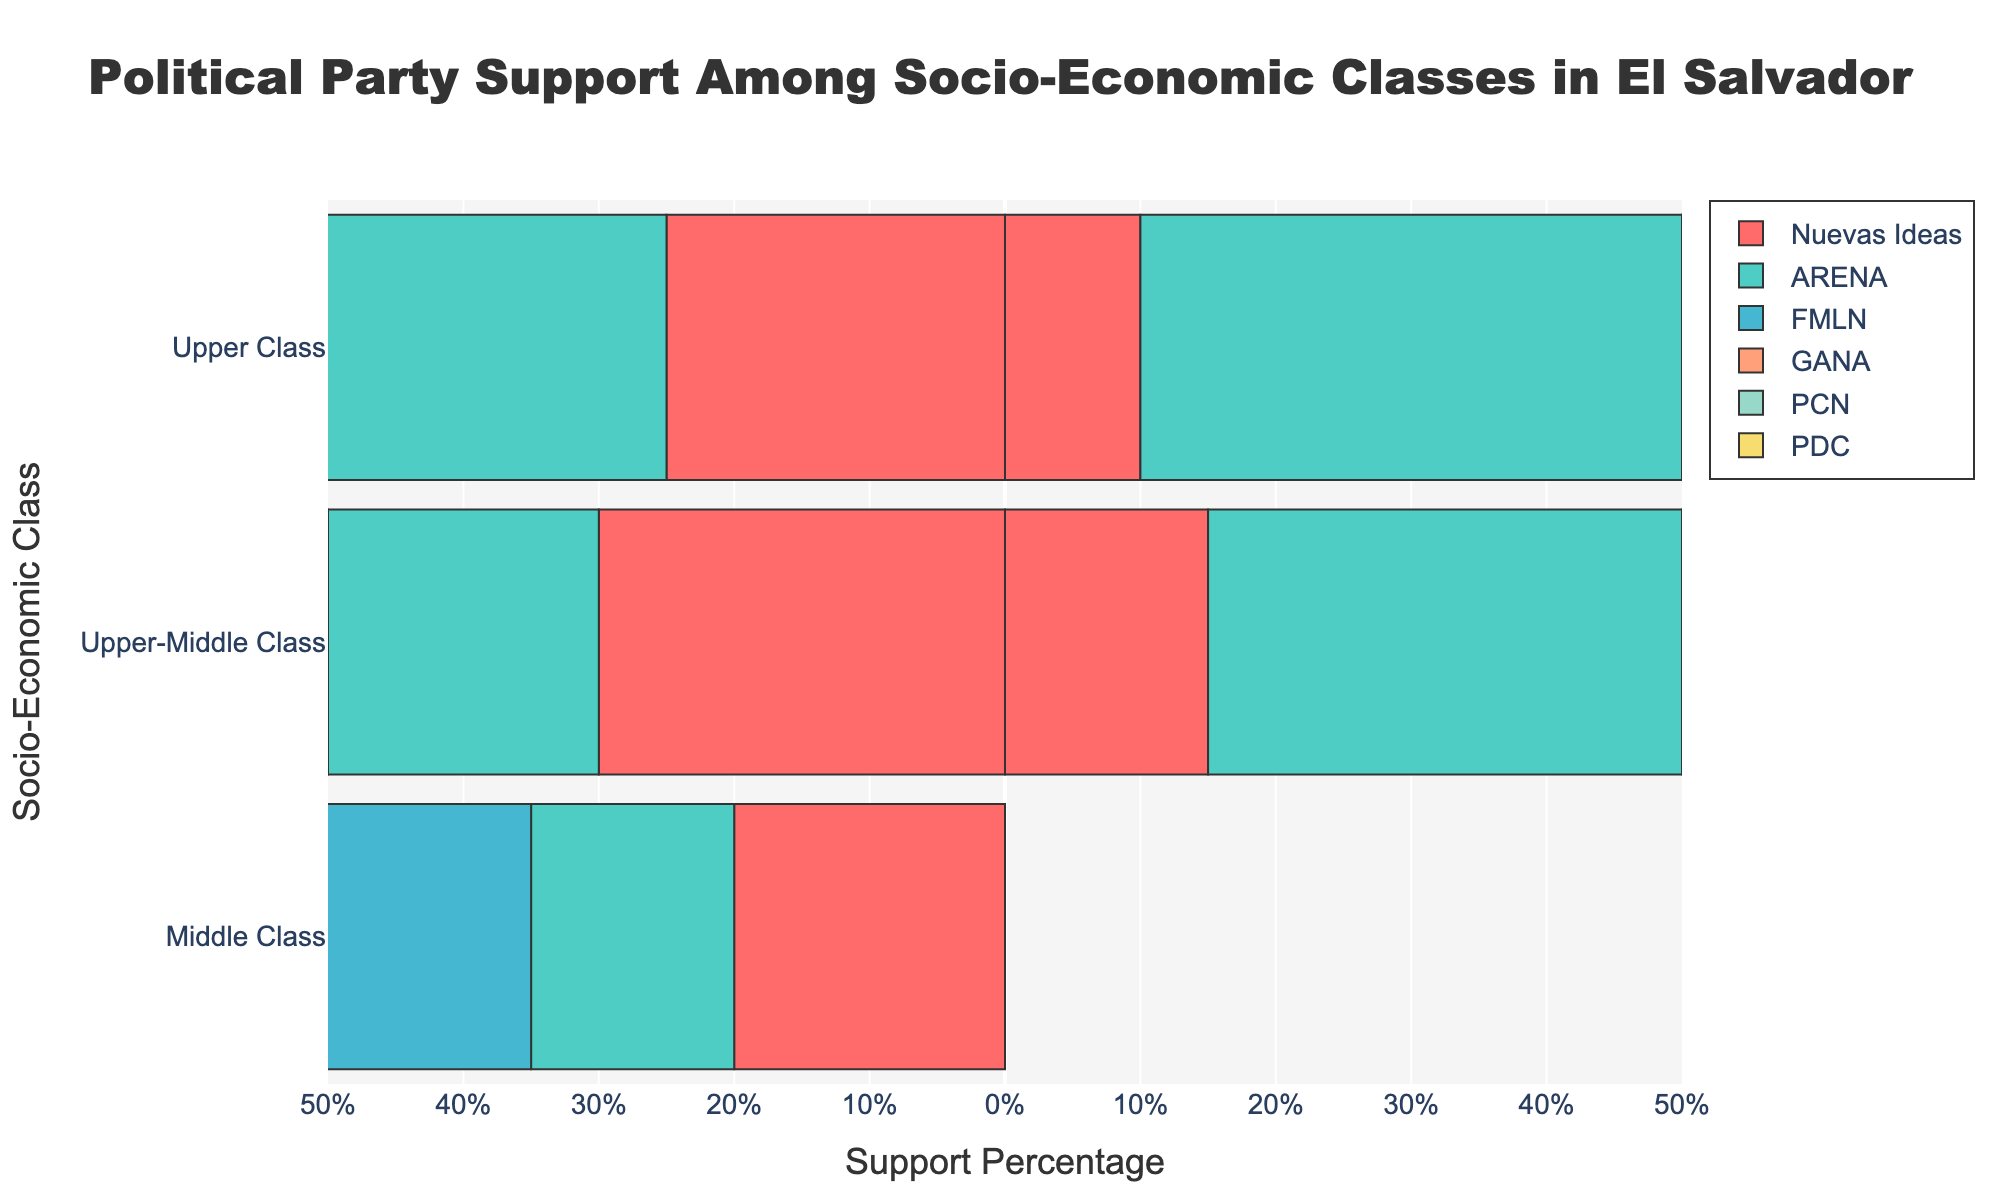Which political party has the highest support among the middle class? Looking at the bar lengths for each party regarding the middle class, the tallest bar represents ARENA with 30%.
Answer: ARENA How does the support for ARENA compare between the upper class and the lower class? By comparing the length of the bars for ARENA among the upper class and the lower class, ARENA has 40% support among the upper class and 15% among the lower class, showing it has more support in the upper class.
Answer: ARENA has more support in the upper class What is the sum of support percentages for Nuevas Ideas and GANA among the lower-middle class? Looking at the lengths of the bars for the lower-middle class, Nuevas Ideas has 30% and GANA has 10%. Adding these together gives 30% + 10% = 40%.
Answer: 40% Which socio-economic class supports FMLN the most? By examining the bars for FMLN across all socio-economic classes, the bar for the lower class is the longest with 45% support.
Answer: Lower class Between PCN and PDC, which party has greater support among the upper-middle class? Comparing the bar lengths for PCN and PDC in the upper-middle class, PCN has 5% while PDC also has 5%, indicating they have equal support.
Answer: They have equal support How does lower class support for Nuevas Ideas compare to its support among the upper-middle class? By comparing the bar lengths for Nuevas Ideas in the lower class and the upper-middle class, the lower class has 20% support while the upper-middle class has 15%. Thus, Nuevas Ideas has slightly more support among the lower class.
Answer: Slightly more support among the lower class What is the average support for PCN across all socio-economic classes? The support for PCN is 10%, 5%, 3%, 3%, and 5% across the socio-economic classes. Summing these gives 26% and dividing by the 5 classes gives an average of 26% / 5 = 5.2%.
Answer: 5.2% For which class is the divergence in political party support the most balanced? Looking at the chart, the middle class appears the most balanced with more evenly distributed bar lengths across the parties, none of which dominate significantly over the others.
Answer: Middle class What is the difference in support for GANA between the middle class and the upper class? The support for GANA is 10% among the middle class and 15% among the upper class. The difference is 15% - 10% = 5%.
Answer: 5% 